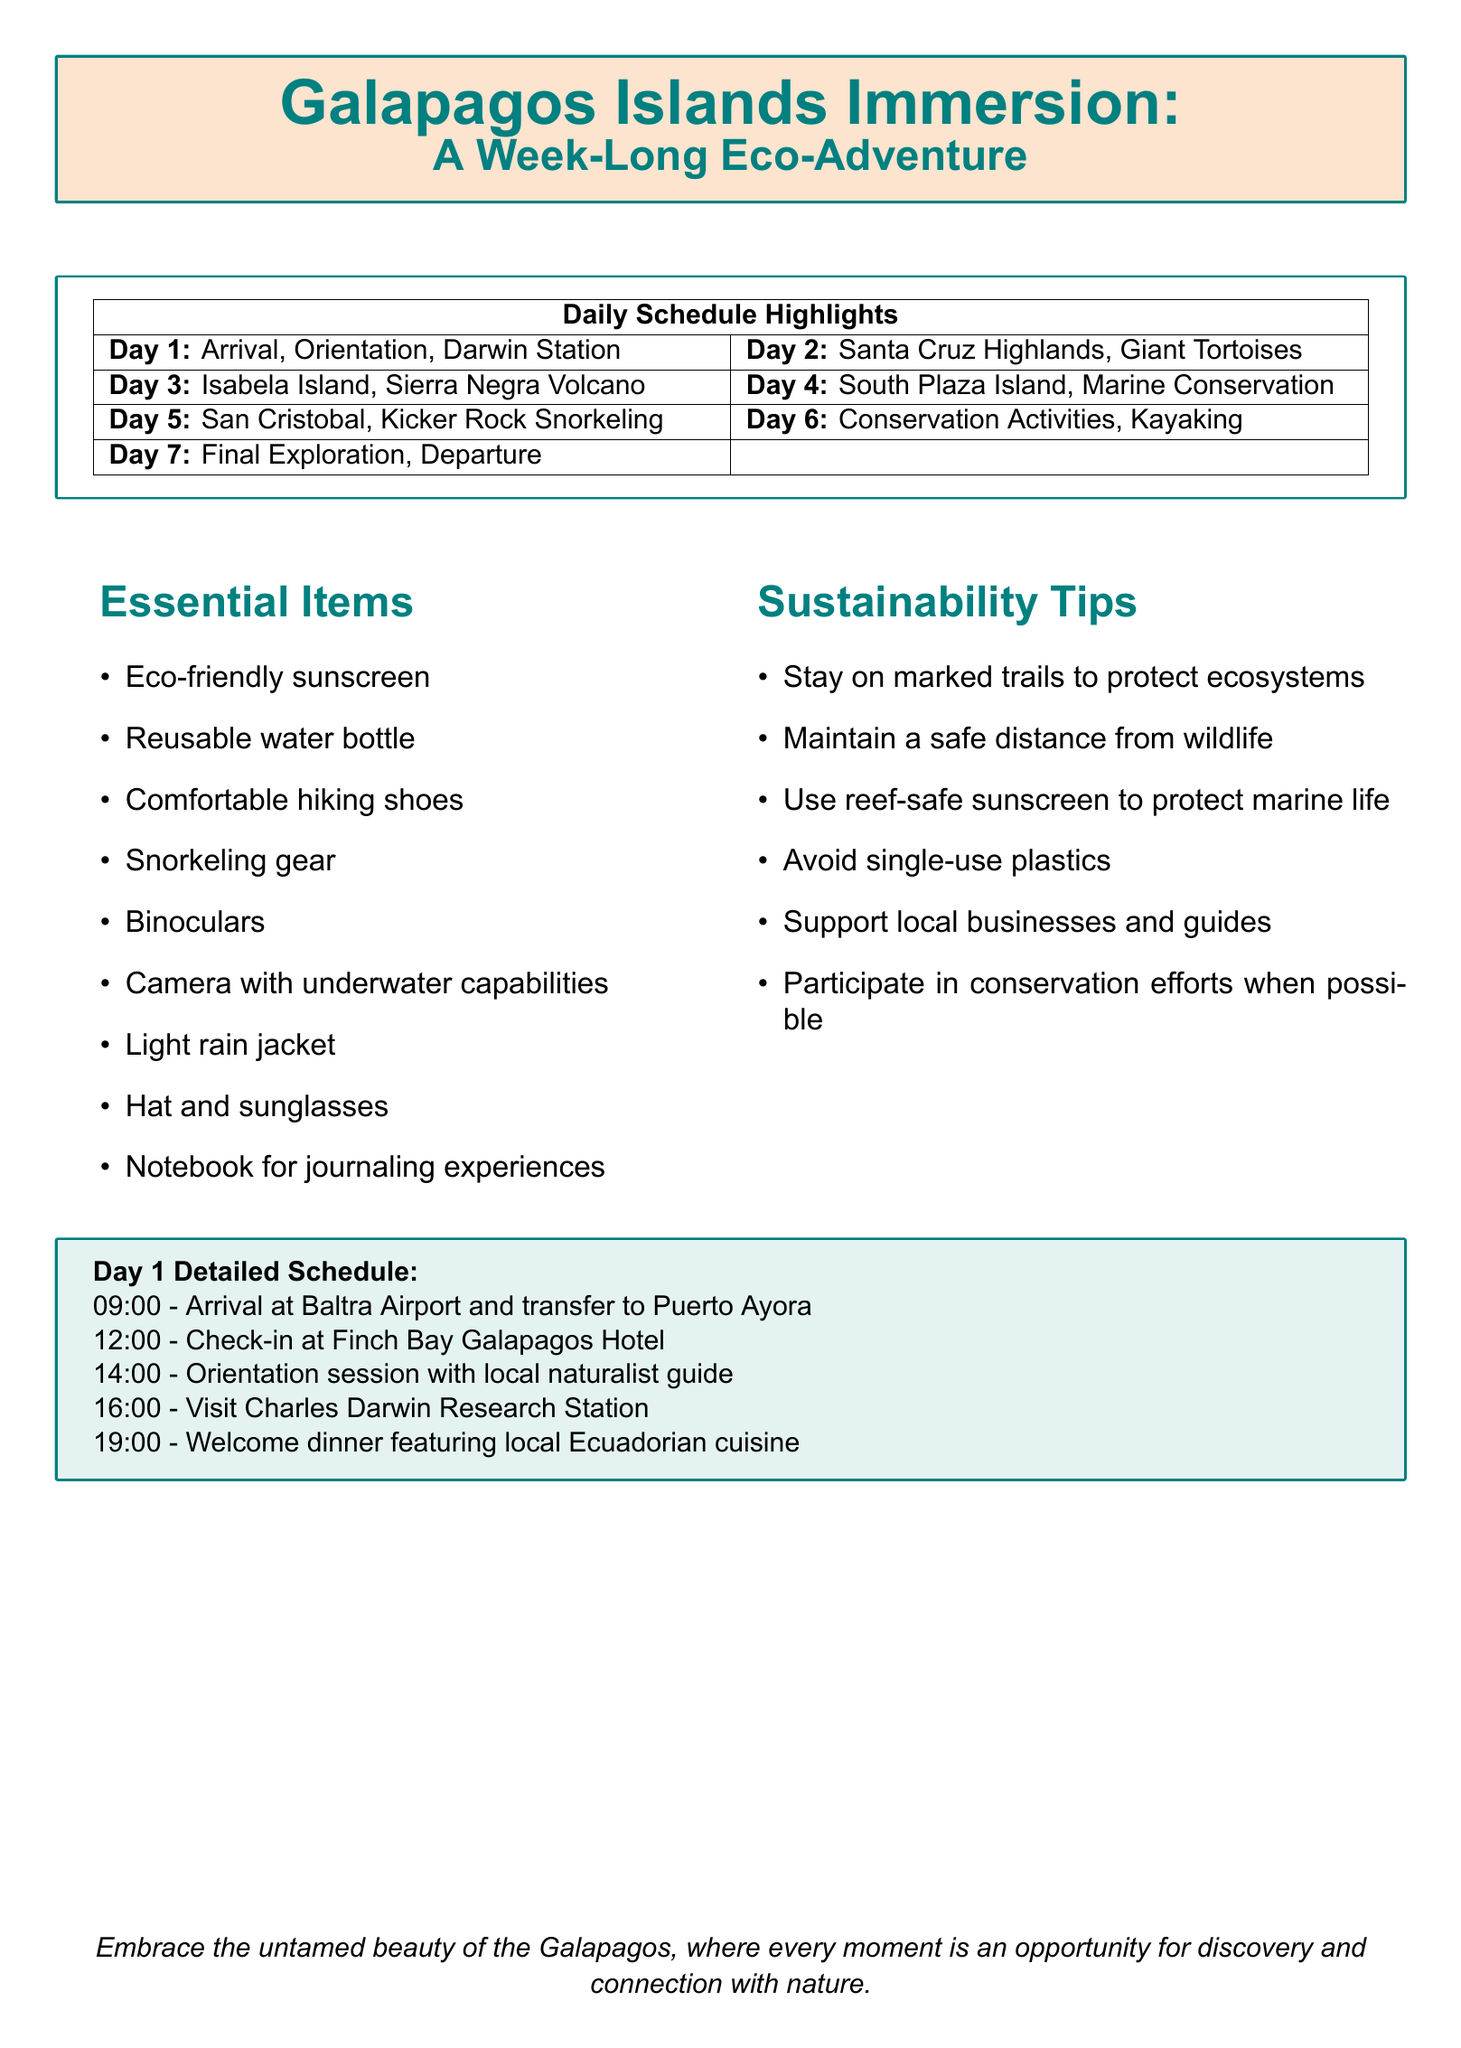What is the title of the agenda? The title of the agenda is provided at the beginning of the document.
Answer: Galapagos Islands Immersion: A Week-Long Eco-Adventure What time does the welcome dinner take place on Day 1? The welcome dinner is listed under Day 1 activities in the document.
Answer: 19:00 Which island is visited on Day 3? The document specifies the destination for Day 3 activities.
Answer: Isabela Island What activity is scheduled for 14:00 on Day 6? This requires knowing the detailed schedule for Day 6 from the document.
Answer: Visit local school to learn about environmental education programs How many essential items are listed in the document? The total number of essential items can be counted from the list provided in the document.
Answer: 9 What type of conservation activity is included on Day 6? The document mentions the types of activities scheduled, focusing on conservation.
Answer: Beach clean-up What is the primary focus of the immersion experience? The document's title and theme convey the purpose of the agenda.
Answer: Eco-Adventure What is a recommended item to bring for snorkeling? This information can be found in the essential items section of the document.
Answer: Snorkeling gear What unique feature does the Sierra Negra Volcano possess? This question infers information about the Sierra Negra Volcano from Day 3's description.
Answer: Second-largest crater in the world 